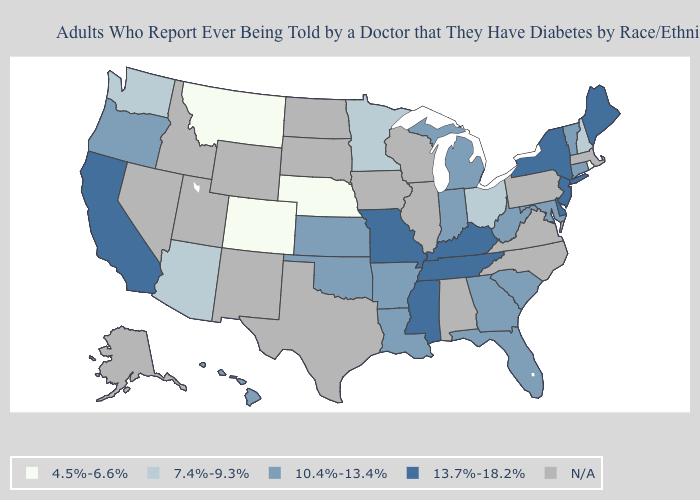Which states hav the highest value in the Northeast?
Write a very short answer. Maine, New Jersey, New York. Name the states that have a value in the range 4.5%-6.6%?
Short answer required. Colorado, Montana, Nebraska, Rhode Island. Does the first symbol in the legend represent the smallest category?
Be succinct. Yes. What is the highest value in states that border North Carolina?
Write a very short answer. 13.7%-18.2%. Which states have the lowest value in the USA?
Concise answer only. Colorado, Montana, Nebraska, Rhode Island. Does the map have missing data?
Concise answer only. Yes. Name the states that have a value in the range 7.4%-9.3%?
Write a very short answer. Arizona, Minnesota, New Hampshire, Ohio, Washington. Which states hav the highest value in the Northeast?
Write a very short answer. Maine, New Jersey, New York. Does Montana have the lowest value in the USA?
Give a very brief answer. Yes. Name the states that have a value in the range N/A?
Quick response, please. Alabama, Alaska, Idaho, Illinois, Iowa, Massachusetts, Nevada, New Mexico, North Carolina, North Dakota, Pennsylvania, South Dakota, Texas, Utah, Virginia, Wisconsin, Wyoming. What is the value of Rhode Island?
Short answer required. 4.5%-6.6%. Does Vermont have the highest value in the Northeast?
Give a very brief answer. No. What is the lowest value in the West?
Give a very brief answer. 4.5%-6.6%. What is the value of South Dakota?
Be succinct. N/A. 